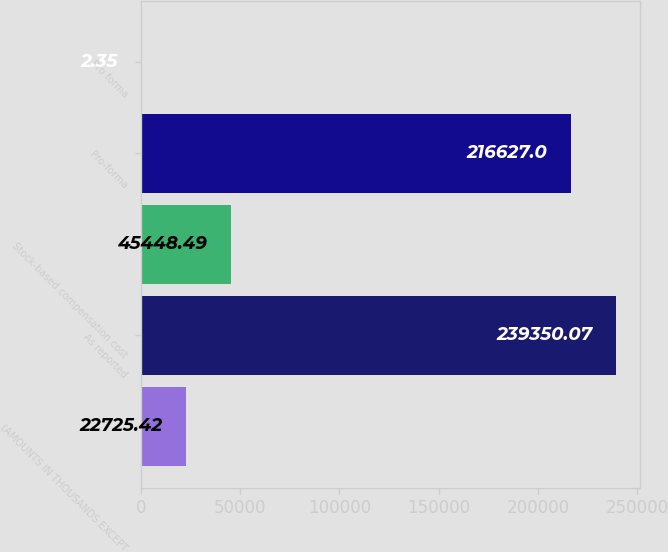Convert chart. <chart><loc_0><loc_0><loc_500><loc_500><bar_chart><fcel>(AMOUNTS IN THOUSANDS EXCEPT<fcel>As reported<fcel>Stock-based compensation cost<fcel>Pro-forma<fcel>Pro forma<nl><fcel>22725.4<fcel>239350<fcel>45448.5<fcel>216627<fcel>2.35<nl></chart> 